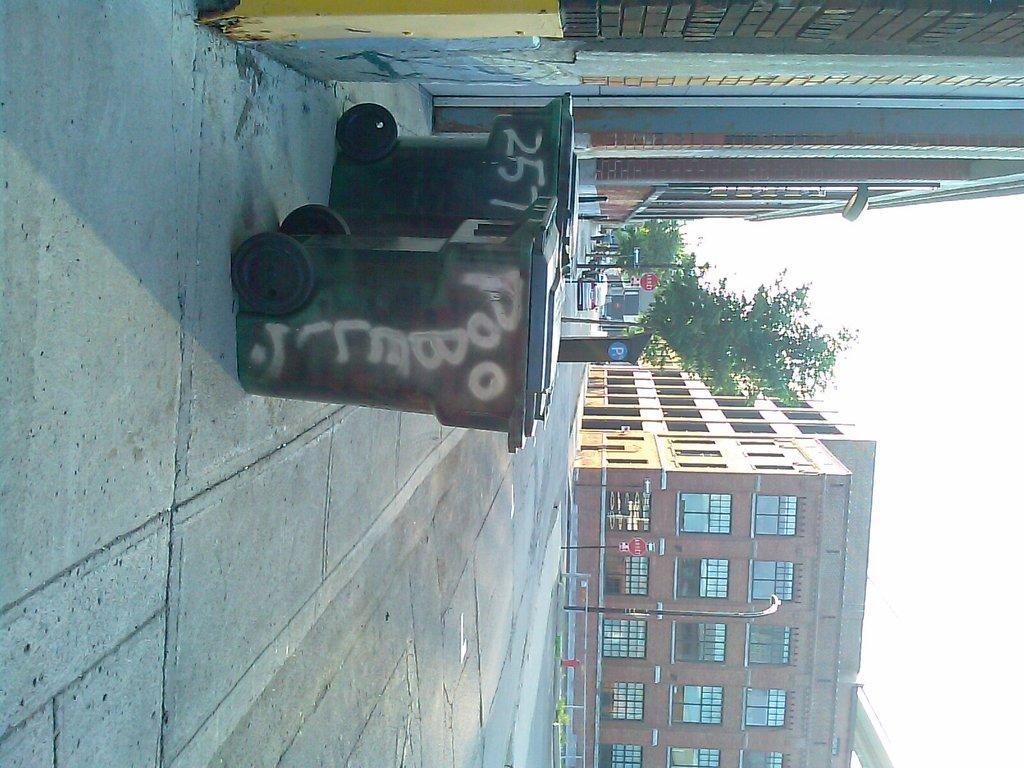What objects are placed in front of a wall in the image? There are trash bins in front of a wall in the image. What type of pathway can be seen in the image? There is a road in the image. What structures are present on either side of the road? There are poles on either side of the road. What type of structures can be seen in the distance? There are buildings visible in the image. What type of vegetation is present in the image? There are trees in the image. What part of the natural environment is visible in the image? The sky is visible in the image. What type of plastic is covering the trees in the image? There is no plastic covering the trees in the image; the trees are not covered. What type of mist can be seen in the image? There is no mist visible in the image. 